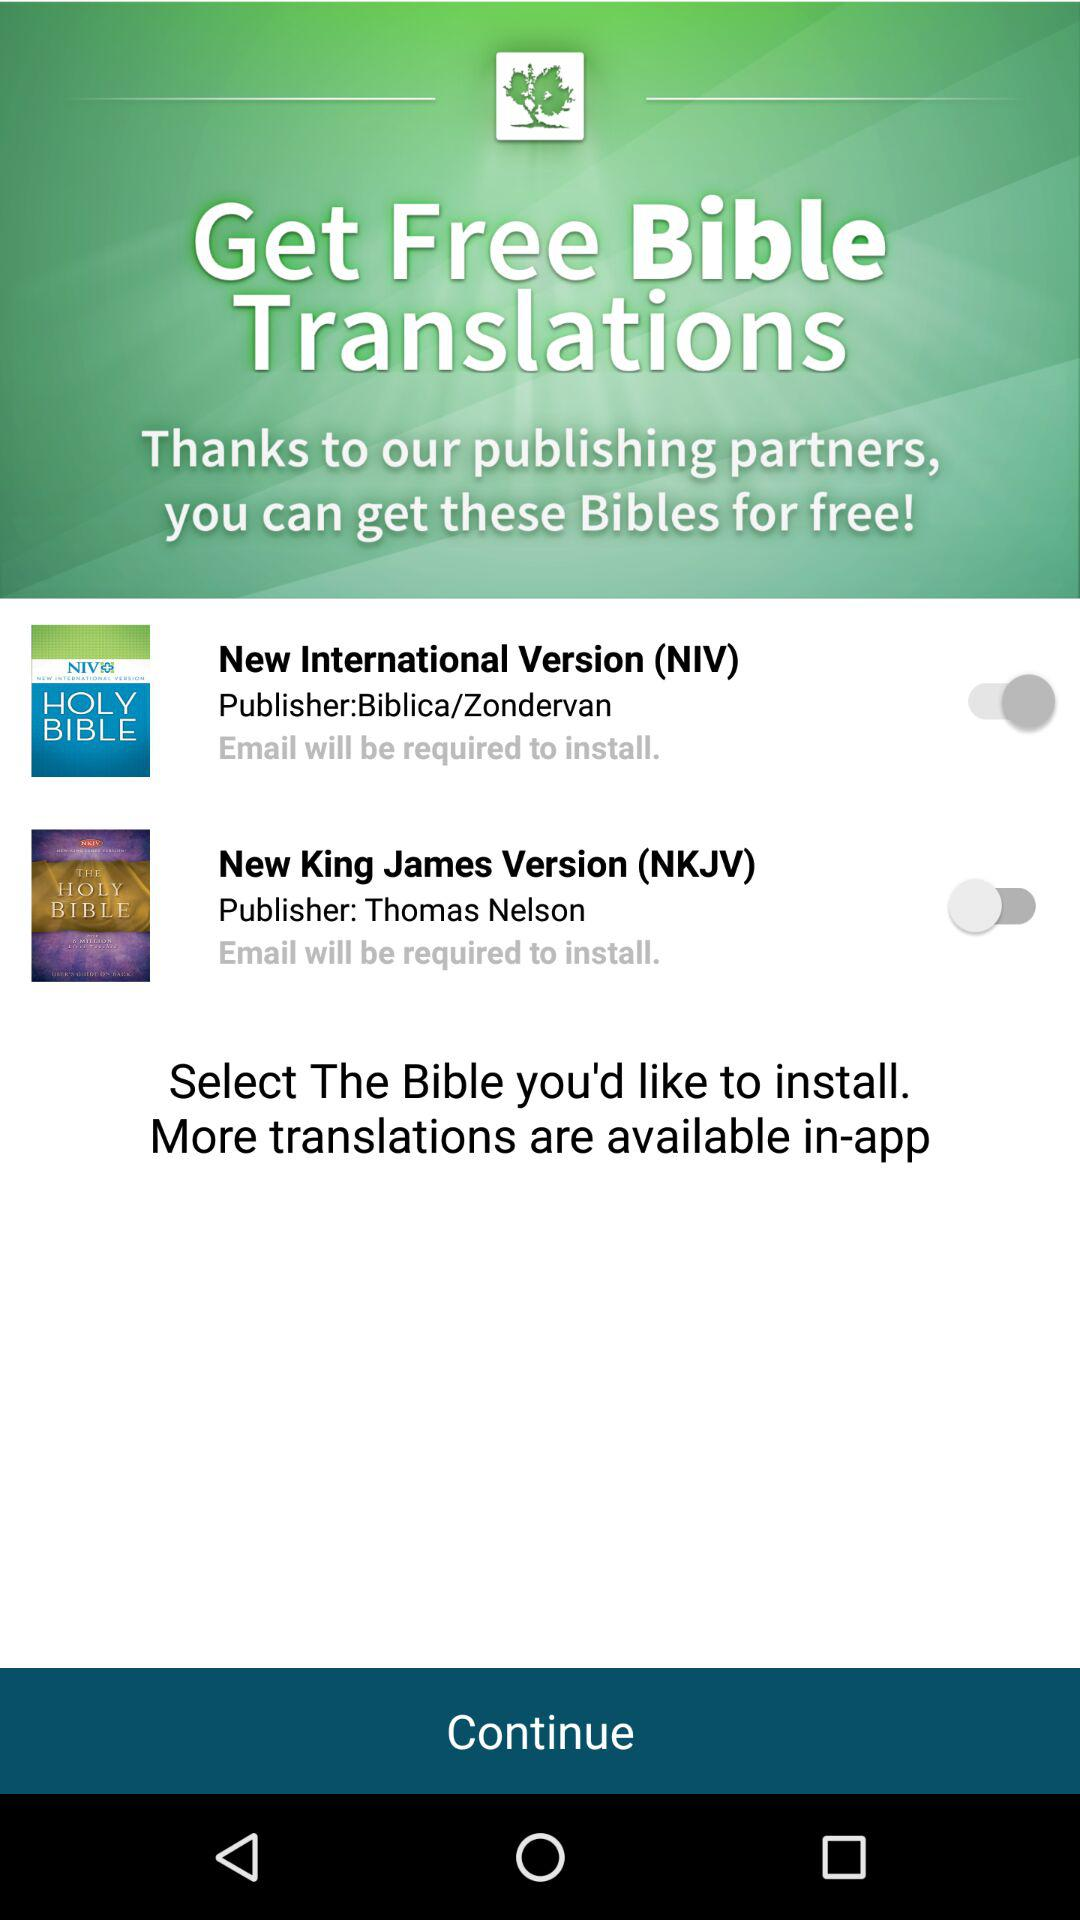How many Bible translations require an email address to install?
Answer the question using a single word or phrase. 2 